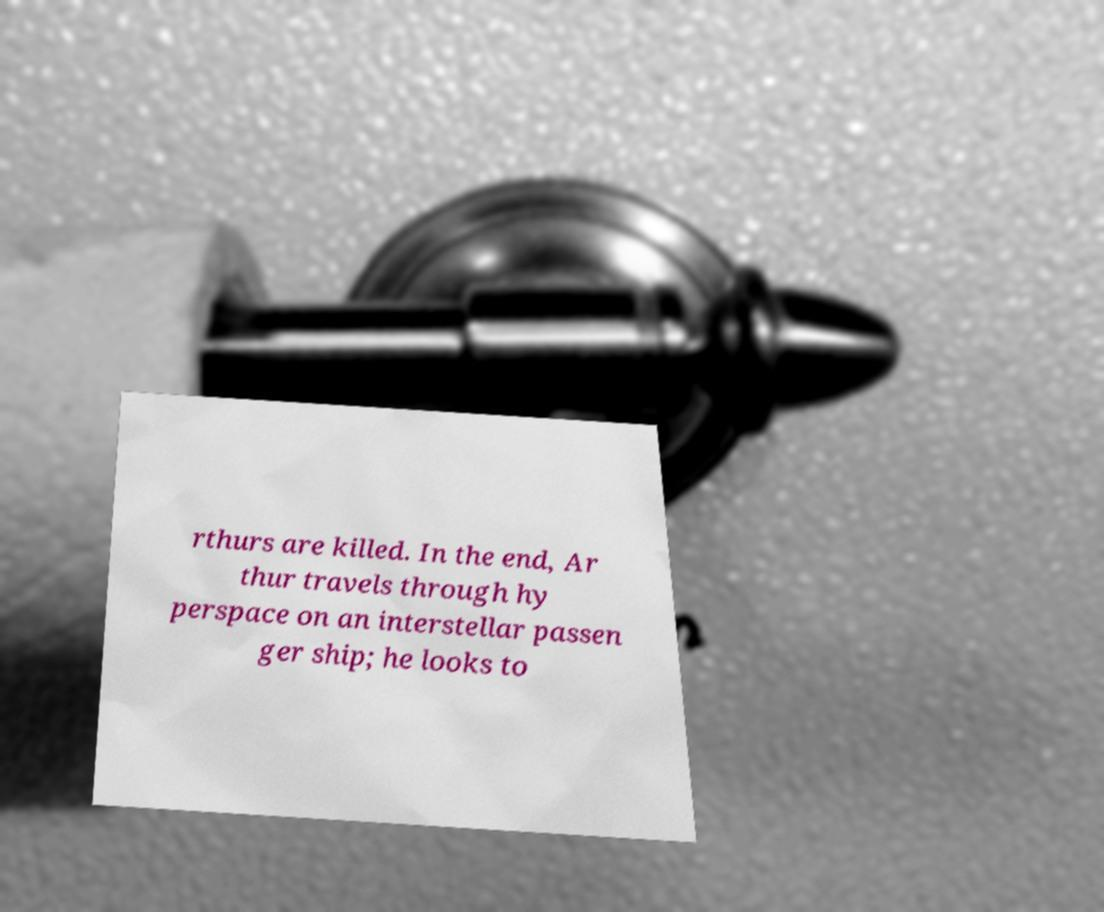Please identify and transcribe the text found in this image. rthurs are killed. In the end, Ar thur travels through hy perspace on an interstellar passen ger ship; he looks to 